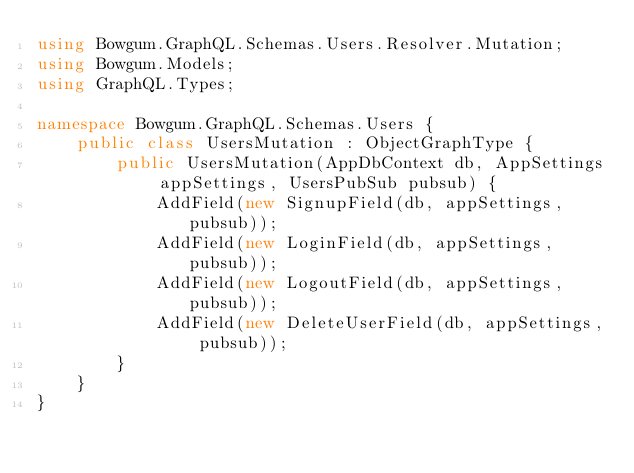Convert code to text. <code><loc_0><loc_0><loc_500><loc_500><_C#_>using Bowgum.GraphQL.Schemas.Users.Resolver.Mutation;
using Bowgum.Models;
using GraphQL.Types;

namespace Bowgum.GraphQL.Schemas.Users {
    public class UsersMutation : ObjectGraphType {
        public UsersMutation(AppDbContext db, AppSettings appSettings, UsersPubSub pubsub) {
            AddField(new SignupField(db, appSettings, pubsub));
            AddField(new LoginField(db, appSettings, pubsub));
            AddField(new LogoutField(db, appSettings, pubsub));
            AddField(new DeleteUserField(db, appSettings, pubsub));
        }
    }
}</code> 